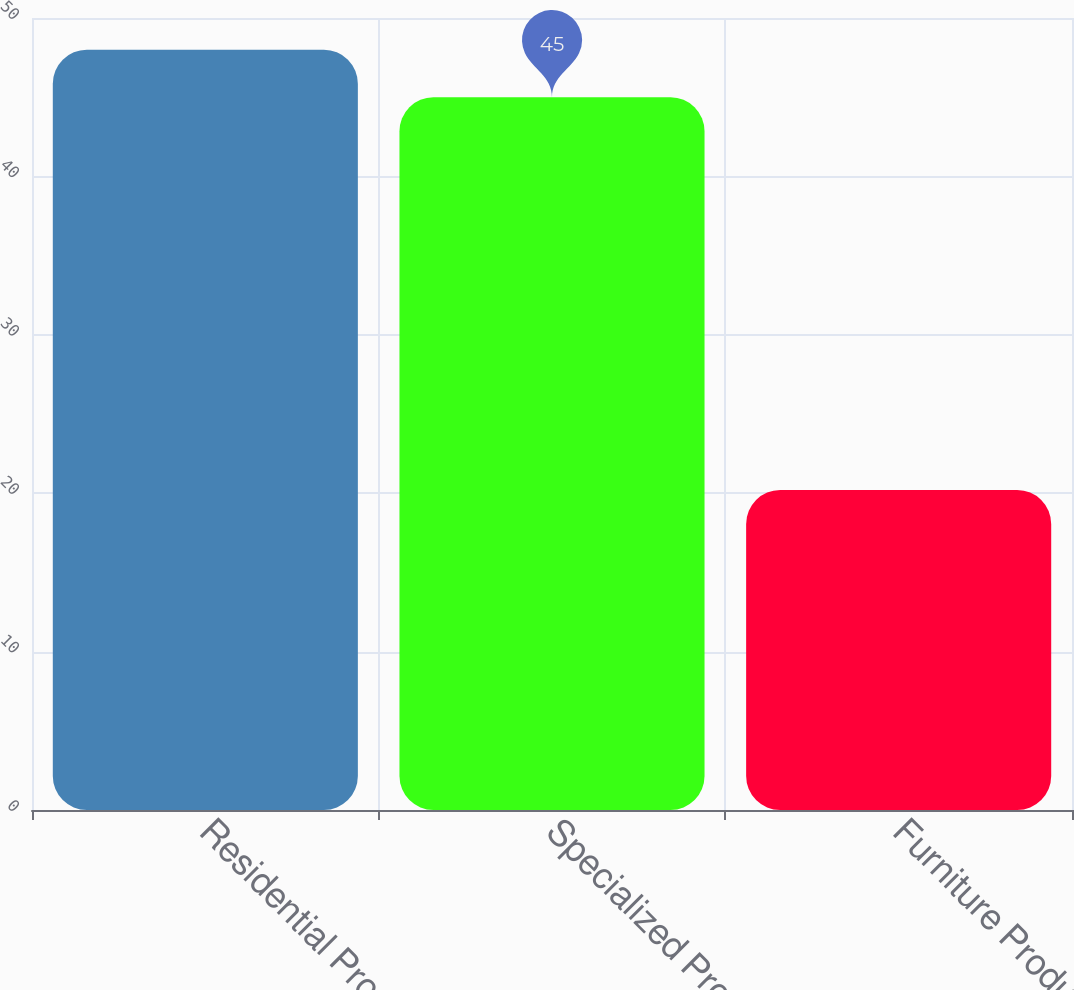Convert chart to OTSL. <chart><loc_0><loc_0><loc_500><loc_500><bar_chart><fcel>Residential Products<fcel>Specialized Products<fcel>Furniture Products<nl><fcel>48<fcel>45<fcel>20.2<nl></chart> 